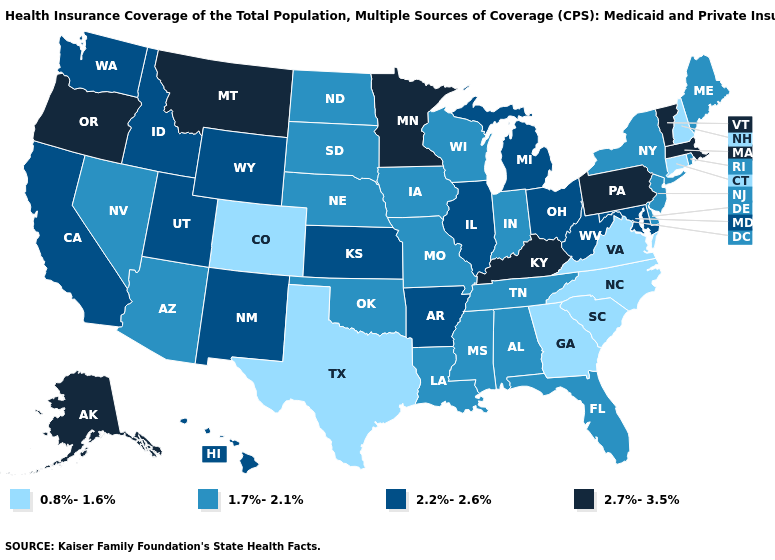Does Tennessee have the same value as Missouri?
Answer briefly. Yes. What is the value of New Hampshire?
Give a very brief answer. 0.8%-1.6%. Does the map have missing data?
Short answer required. No. Name the states that have a value in the range 2.2%-2.6%?
Give a very brief answer. Arkansas, California, Hawaii, Idaho, Illinois, Kansas, Maryland, Michigan, New Mexico, Ohio, Utah, Washington, West Virginia, Wyoming. What is the highest value in the USA?
Be succinct. 2.7%-3.5%. Does the first symbol in the legend represent the smallest category?
Give a very brief answer. Yes. Is the legend a continuous bar?
Short answer required. No. What is the highest value in the Northeast ?
Short answer required. 2.7%-3.5%. Does Maryland have the lowest value in the South?
Give a very brief answer. No. Which states have the highest value in the USA?
Give a very brief answer. Alaska, Kentucky, Massachusetts, Minnesota, Montana, Oregon, Pennsylvania, Vermont. Among the states that border Maine , which have the highest value?
Concise answer only. New Hampshire. What is the value of Ohio?
Be succinct. 2.2%-2.6%. Among the states that border South Dakota , does Minnesota have the highest value?
Quick response, please. Yes. Name the states that have a value in the range 1.7%-2.1%?
Concise answer only. Alabama, Arizona, Delaware, Florida, Indiana, Iowa, Louisiana, Maine, Mississippi, Missouri, Nebraska, Nevada, New Jersey, New York, North Dakota, Oklahoma, Rhode Island, South Dakota, Tennessee, Wisconsin. Name the states that have a value in the range 0.8%-1.6%?
Answer briefly. Colorado, Connecticut, Georgia, New Hampshire, North Carolina, South Carolina, Texas, Virginia. 